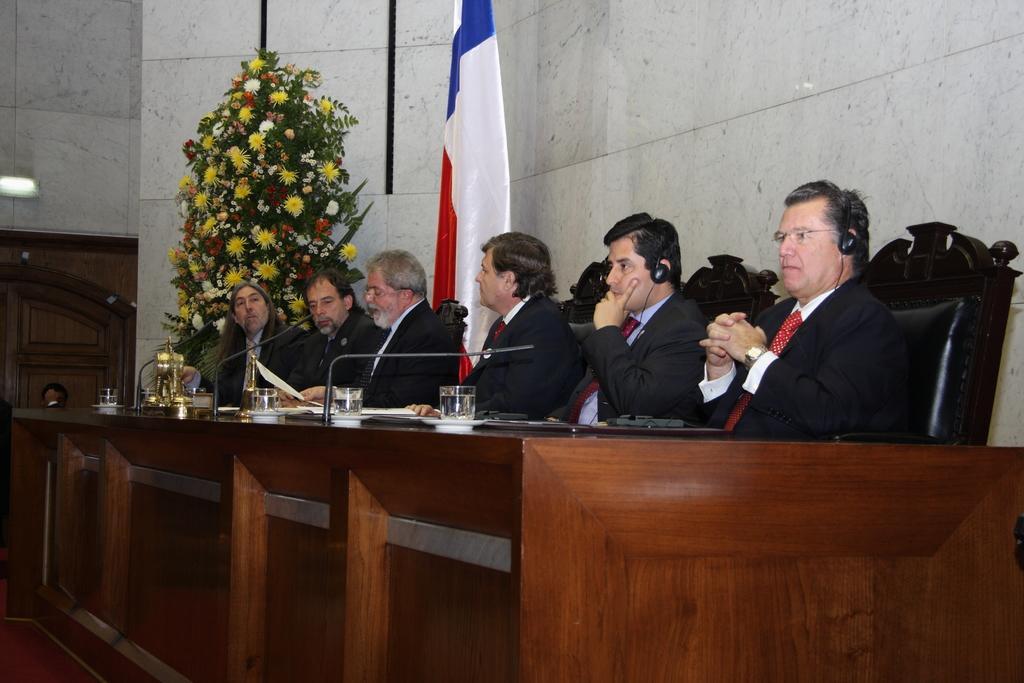How would you summarize this image in a sentence or two? In this image we can see a group of people sitting on the chairs. In that two men are wearing the headset. We can also see a table in front of them containing some glasses, mics with stand and some papers on it. On the backside we can see a door, wall, a ceiling light, a flower bouquet and the flag. 